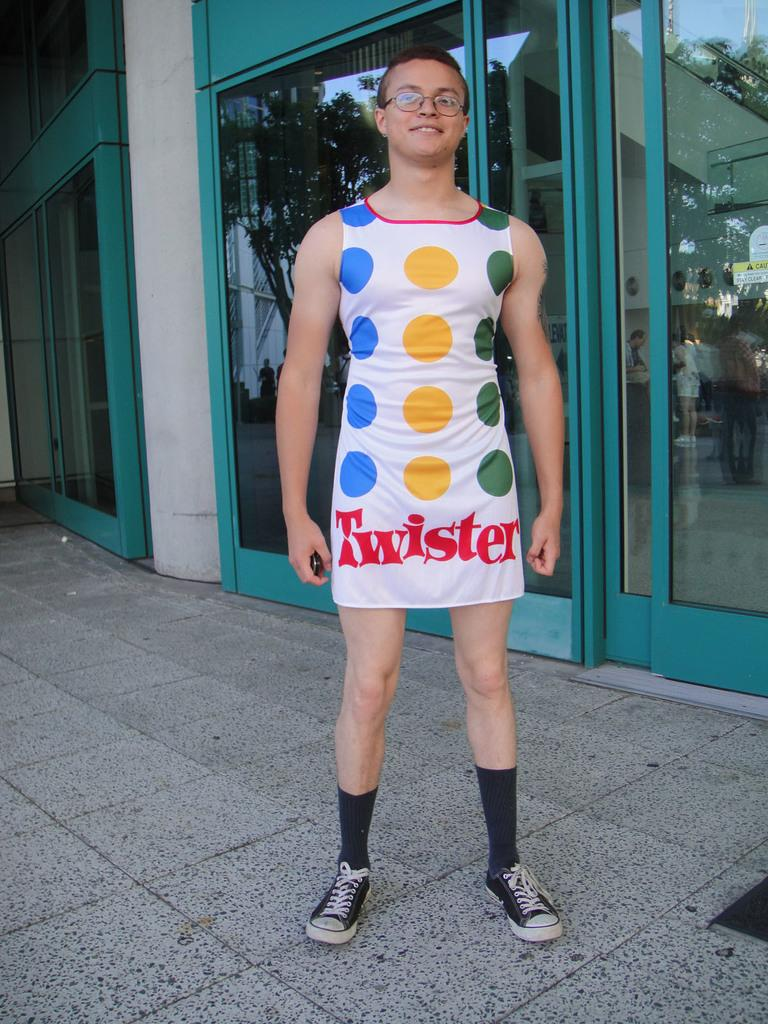<image>
Write a terse but informative summary of the picture. A young man in galsses stands outside a store wearing a twister themed dress. 